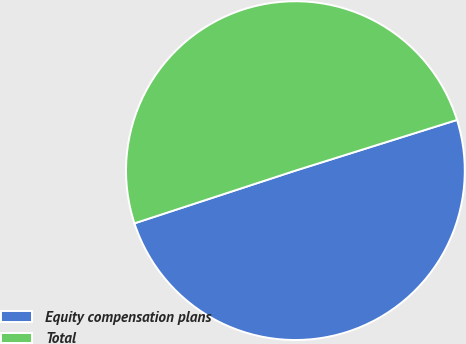Convert chart to OTSL. <chart><loc_0><loc_0><loc_500><loc_500><pie_chart><fcel>Equity compensation plans<fcel>Total<nl><fcel>49.8%<fcel>50.2%<nl></chart> 